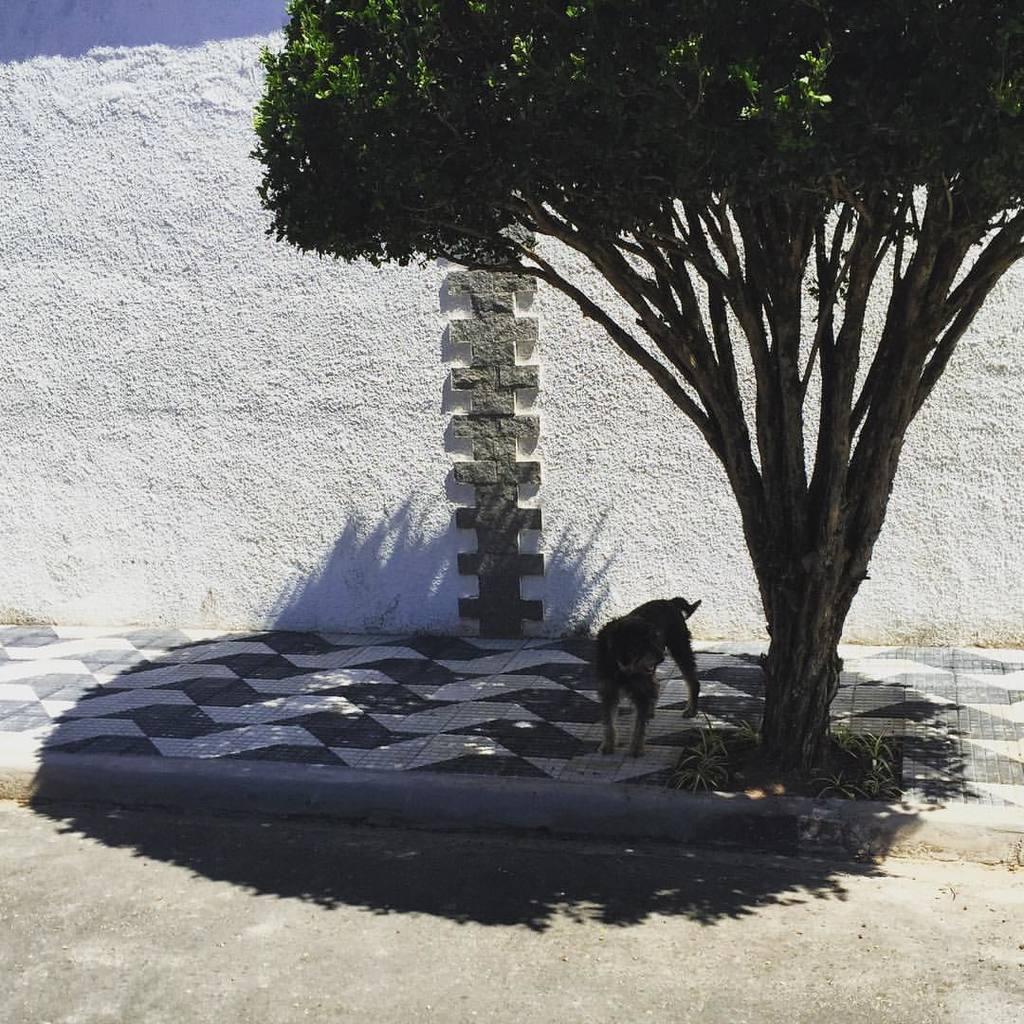Describe this image in one or two sentences. In this picture I can see a wall, a dog and a tree. 